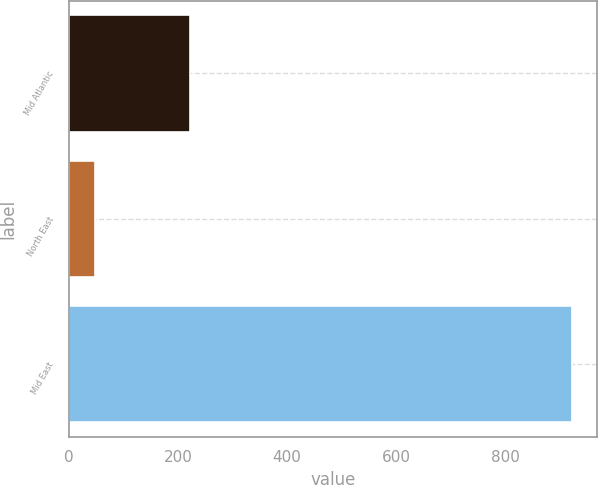<chart> <loc_0><loc_0><loc_500><loc_500><bar_chart><fcel>Mid Atlantic<fcel>North East<fcel>Mid East<nl><fcel>222<fcel>47<fcel>923<nl></chart> 